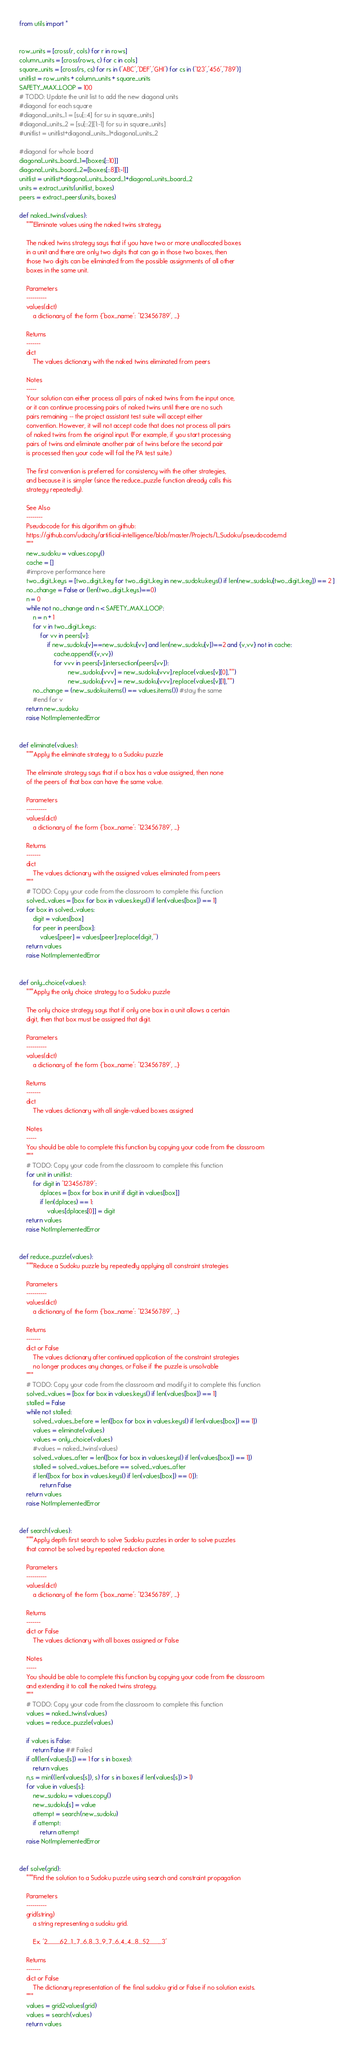Convert code to text. <code><loc_0><loc_0><loc_500><loc_500><_Python_>
from utils import *


row_units = [cross(r, cols) for r in rows]
column_units = [cross(rows, c) for c in cols]
square_units = [cross(rs, cs) for rs in ('ABC','DEF','GHI') for cs in ('123','456','789')]
unitlist = row_units + column_units + square_units
SAFETY_MAX_LOOP = 100
# TODO: Update the unit list to add the new diagonal units
#diagonal for each square
#diagonal_units_1 = [su[::4] for su in square_units]
#diagonal_units_2 = [su[::2][1:-1] for su in square_units]
#unitlist = unitlist+diagonal_units_1+diagonal_units_2

#diagonal for whole board
diagonal_units_board_1=[boxes[::10]]
diagonal_units_board_2=[boxes[::8][1:-1]]
unitlist = unitlist+diagonal_units_board_1+diagonal_units_board_2
units = extract_units(unitlist, boxes)
peers = extract_peers(units, boxes)

def naked_twins(values):
    """Eliminate values using the naked twins strategy.

    The naked twins strategy says that if you have two or more unallocated boxes
    in a unit and there are only two digits that can go in those two boxes, then
    those two digits can be eliminated from the possible assignments of all other
    boxes in the same unit.

    Parameters
    ----------
    values(dict)
        a dictionary of the form {'box_name': '123456789', ...}

    Returns
    -------
    dict
        The values dictionary with the naked twins eliminated from peers

    Notes
    -----
    Your solution can either process all pairs of naked twins from the input once,
    or it can continue processing pairs of naked twins until there are no such
    pairs remaining -- the project assistant test suite will accept either
    convention. However, it will not accept code that does not process all pairs
    of naked twins from the original input. (For example, if you start processing
    pairs of twins and eliminate another pair of twins before the second pair
    is processed then your code will fail the PA test suite.)

    The first convention is preferred for consistency with the other strategies,
    and because it is simpler (since the reduce_puzzle function already calls this
    strategy repeatedly).

    See Also
    --------
    Pseudocode for this algorithm on github:
    https://github.com/udacity/artificial-intelligence/blob/master/Projects/1_Sudoku/pseudocode.md
    """
    new_sudoku = values.copy()
    cache = []
    #improve performance here
    two_digit_keys = [two_digit_key for two_digit_key in new_sudoku.keys() if len(new_sudoku[two_digit_key]) == 2 ]
    no_change = False or (len(two_digit_keys)==0)
    n = 0
    while not no_change and n < SAFETY_MAX_LOOP:
        n = n + 1
        for v in two_digit_keys:
            for vv in peers[v]:
                if new_sudoku[v]==new_sudoku[vv] and len(new_sudoku[v])==2 and {v,vv} not in cache:
                    cache.append({v,vv})
                    for vvv in peers[v].intersection(peers[vv]):
                            new_sudoku[vvv] = new_sudoku[vvv].replace(values[v][0],"")
                            new_sudoku[vvv] = new_sudoku[vvv].replace(values[v][1],"")
        no_change = (new_sudoku.items() == values.items()) #stay the same
        #end for v
    return new_sudoku
    raise NotImplementedError


def eliminate(values):
    """Apply the eliminate strategy to a Sudoku puzzle

    The eliminate strategy says that if a box has a value assigned, then none
    of the peers of that box can have the same value.

    Parameters
    ----------
    values(dict)
        a dictionary of the form {'box_name': '123456789', ...}

    Returns
    -------
    dict
        The values dictionary with the assigned values eliminated from peers
    """
    # TODO: Copy your code from the classroom to complete this function
    solved_values = [box for box in values.keys() if len(values[box]) == 1]
    for box in solved_values:
        digit = values[box]
        for peer in peers[box]:
            values[peer] = values[peer].replace(digit,'')
    return values
    raise NotImplementedError


def only_choice(values):
    """Apply the only choice strategy to a Sudoku puzzle

    The only choice strategy says that if only one box in a unit allows a certain
    digit, then that box must be assigned that digit.

    Parameters
    ----------
    values(dict)
        a dictionary of the form {'box_name': '123456789', ...}

    Returns
    -------
    dict
        The values dictionary with all single-valued boxes assigned

    Notes
    -----
    You should be able to complete this function by copying your code from the classroom
    """
    # TODO: Copy your code from the classroom to complete this function
    for unit in unitlist:
        for digit in '123456789':
            dplaces = [box for box in unit if digit in values[box]]
            if len(dplaces) == 1:
                values[dplaces[0]] = digit
    return values
    raise NotImplementedError


def reduce_puzzle(values):
    """Reduce a Sudoku puzzle by repeatedly applying all constraint strategies

    Parameters
    ----------
    values(dict)
        a dictionary of the form {'box_name': '123456789', ...}

    Returns
    -------
    dict or False
        The values dictionary after continued application of the constraint strategies
        no longer produces any changes, or False if the puzzle is unsolvable 
    """
    # TODO: Copy your code from the classroom and modify it to complete this function
    solved_values = [box for box in values.keys() if len(values[box]) == 1]
    stalled = False
    while not stalled:
        solved_values_before = len([box for box in values.keys() if len(values[box]) == 1])
        values = eliminate(values)
        values = only_choice(values)
        #values = naked_twins(values)
        solved_values_after = len([box for box in values.keys() if len(values[box]) == 1])
        stalled = solved_values_before == solved_values_after
        if len([box for box in values.keys() if len(values[box]) == 0]):
            return False
    return values
    raise NotImplementedError


def search(values):
    """Apply depth first search to solve Sudoku puzzles in order to solve puzzles
    that cannot be solved by repeated reduction alone.

    Parameters
    ----------
    values(dict)
        a dictionary of the form {'box_name': '123456789', ...}

    Returns
    -------
    dict or False
        The values dictionary with all boxes assigned or False

    Notes
    -----
    You should be able to complete this function by copying your code from the classroom
    and extending it to call the naked twins strategy.
    """
    # TODO: Copy your code from the classroom to complete this function
    values = naked_twins(values)
    values = reduce_puzzle(values)
    
    if values is False:
        return False ## Failed
    if all(len(values[s]) == 1 for s in boxes): 
        return values 
    n,s = min((len(values[s]), s) for s in boxes if len(values[s]) > 1)
    for value in values[s]:
        new_sudoku = values.copy()
        new_sudoku[s] = value
        attempt = search(new_sudoku)
        if attempt:
            return attempt
    raise NotImplementedError


def solve(grid):
    """Find the solution to a Sudoku puzzle using search and constraint propagation

    Parameters
    ----------
    grid(string)
        a string representing a sudoku grid.
        
        Ex. '2.............62....1....7...6..8...3...9...7...6..4...4....8....52.............3'

    Returns
    -------
    dict or False
        The dictionary representation of the final sudoku grid or False if no solution exists.
    """
    values = grid2values(grid)
    values = search(values)
    return values

</code> 